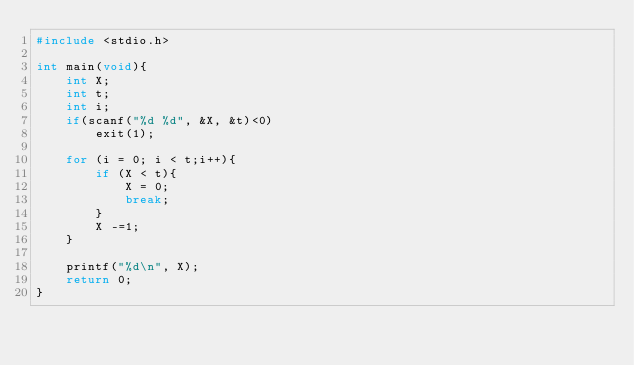<code> <loc_0><loc_0><loc_500><loc_500><_C_>#include <stdio.h>

int main(void){
	int X;
	int t;
	int i;
	if(scanf("%d %d", &X, &t)<0)
		exit(1);
	
	for (i = 0; i < t;i++){
		if (X < t){
			X = 0;
			break;
		}
		X -=1;
	}
	
	printf("%d\n", X);
	return 0;
}</code> 